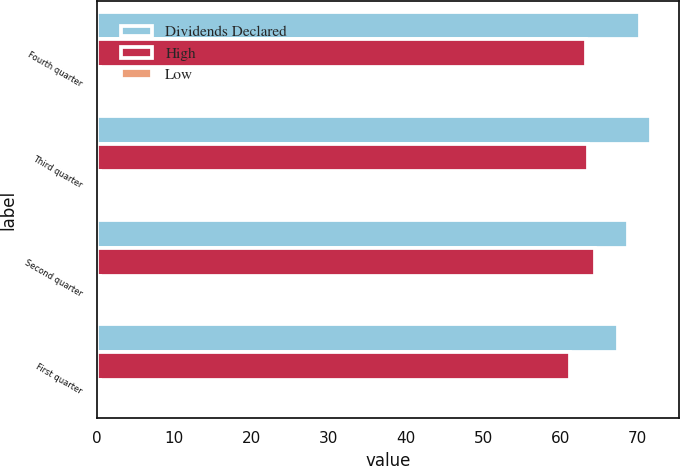Convert chart. <chart><loc_0><loc_0><loc_500><loc_500><stacked_bar_chart><ecel><fcel>Fourth quarter<fcel>Third quarter<fcel>Second quarter<fcel>First quarter<nl><fcel>Dividends Declared<fcel>70.29<fcel>71.77<fcel>68.77<fcel>67.48<nl><fcel>High<fcel>63.34<fcel>63.59<fcel>64.43<fcel>61.29<nl><fcel>Low<fcel>0.47<fcel>0.47<fcel>0.47<fcel>0.47<nl></chart> 